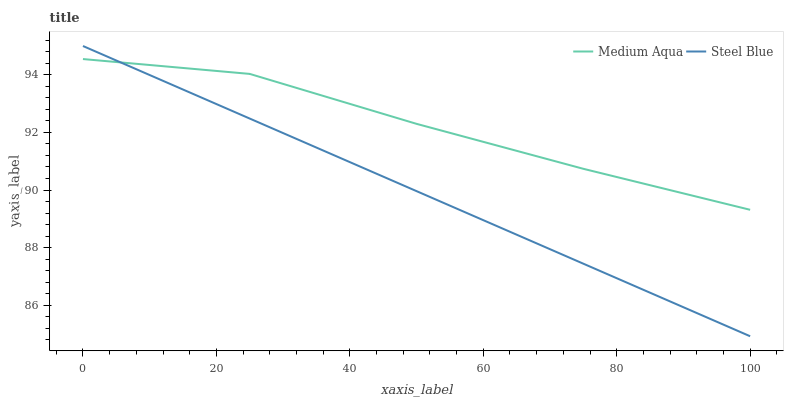Does Steel Blue have the maximum area under the curve?
Answer yes or no. No. Is Steel Blue the roughest?
Answer yes or no. No. 